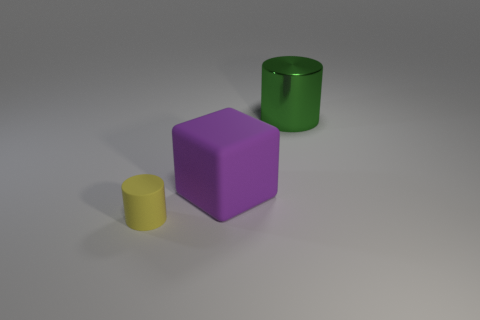Does the big thing that is in front of the large green shiny object have the same color as the object that is to the left of the large rubber block?
Provide a short and direct response. No. What number of other objects are there of the same size as the matte cylinder?
Keep it short and to the point. 0. There is a big object that is in front of the cylinder behind the small cylinder; is there a big purple rubber object to the left of it?
Provide a succinct answer. No. Is the big thing that is in front of the metal object made of the same material as the tiny cylinder?
Ensure brevity in your answer.  Yes. What color is the other object that is the same shape as the tiny yellow matte object?
Keep it short and to the point. Green. Is there any other thing that has the same shape as the small yellow matte thing?
Your answer should be very brief. Yes. Are there an equal number of things that are in front of the large block and green shiny things?
Provide a short and direct response. Yes. Are there any purple matte objects right of the large purple matte object?
Provide a succinct answer. No. There is a rubber object to the right of the object that is on the left side of the large thing that is to the left of the big cylinder; what is its size?
Provide a short and direct response. Large. Is the shape of the big object that is on the left side of the green shiny object the same as the matte thing that is to the left of the big rubber block?
Keep it short and to the point. No. 